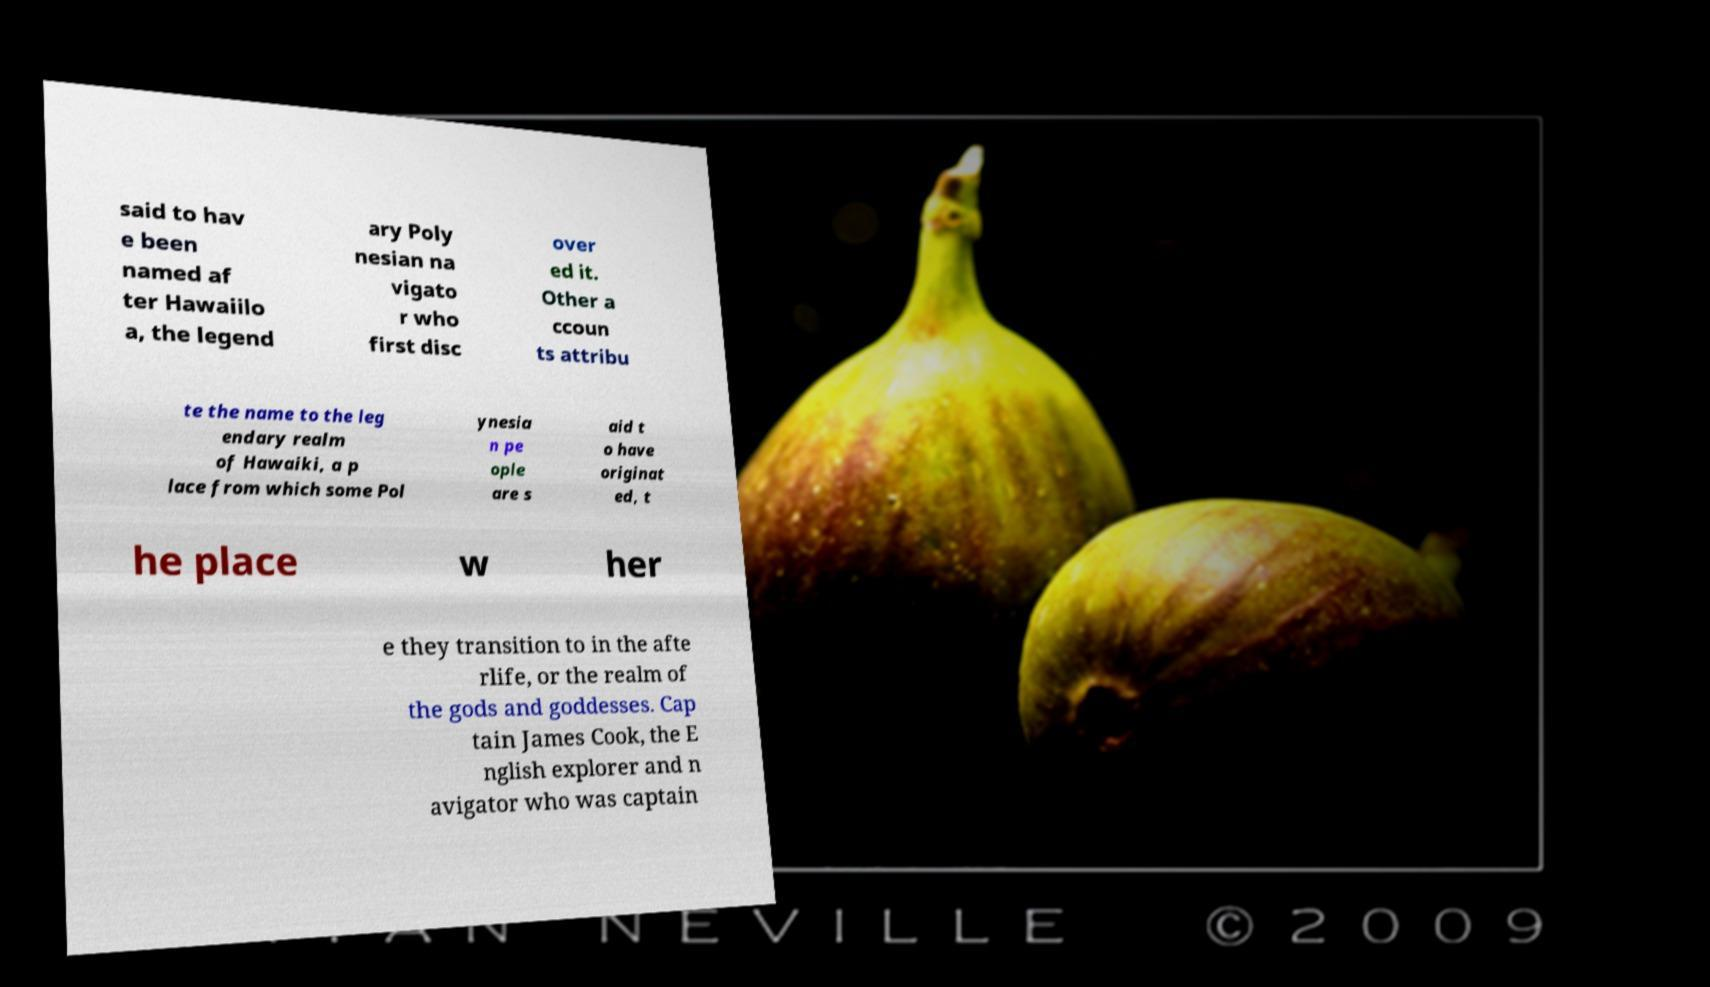Could you assist in decoding the text presented in this image and type it out clearly? said to hav e been named af ter Hawaiilo a, the legend ary Poly nesian na vigato r who first disc over ed it. Other a ccoun ts attribu te the name to the leg endary realm of Hawaiki, a p lace from which some Pol ynesia n pe ople are s aid t o have originat ed, t he place w her e they transition to in the afte rlife, or the realm of the gods and goddesses. Cap tain James Cook, the E nglish explorer and n avigator who was captain 